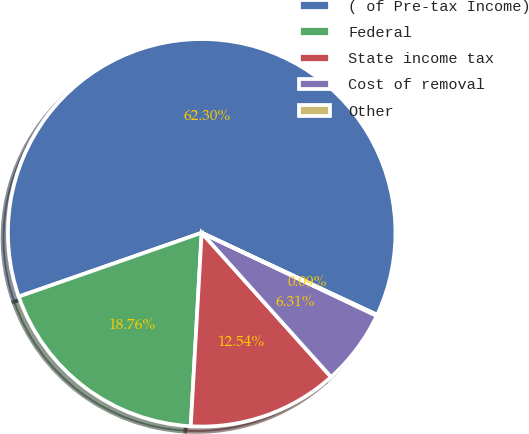Convert chart to OTSL. <chart><loc_0><loc_0><loc_500><loc_500><pie_chart><fcel>( of Pre-tax Income)<fcel>Federal<fcel>State income tax<fcel>Cost of removal<fcel>Other<nl><fcel>62.3%<fcel>18.76%<fcel>12.54%<fcel>6.31%<fcel>0.09%<nl></chart> 